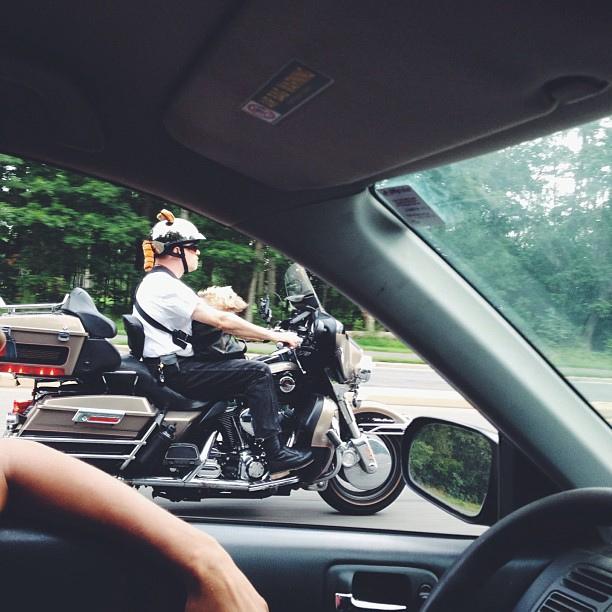Is this picture taken from a car?
Be succinct. Yes. What is on the side mirror?
Quick response, please. Trees. What two things are blue?
Answer briefly. Nothing. What is the motorcycle rider wearing on his head?
Give a very brief answer. Helmet. 